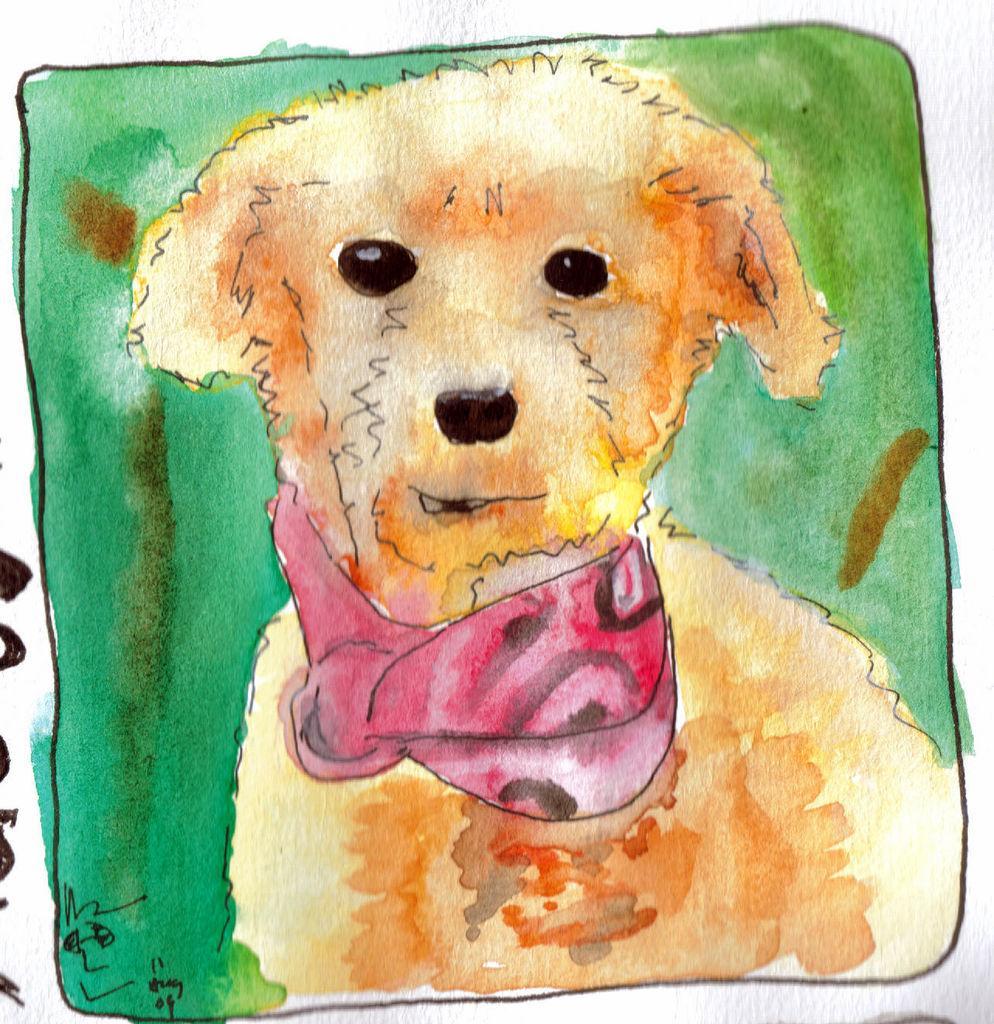How would you summarize this image in a sentence or two? In the image there is a painting of a dog. 